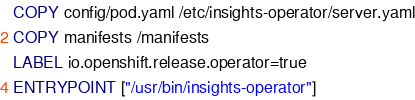Convert code to text. <code><loc_0><loc_0><loc_500><loc_500><_Dockerfile_>COPY config/pod.yaml /etc/insights-operator/server.yaml
COPY manifests /manifests
LABEL io.openshift.release.operator=true
ENTRYPOINT ["/usr/bin/insights-operator"]
</code> 